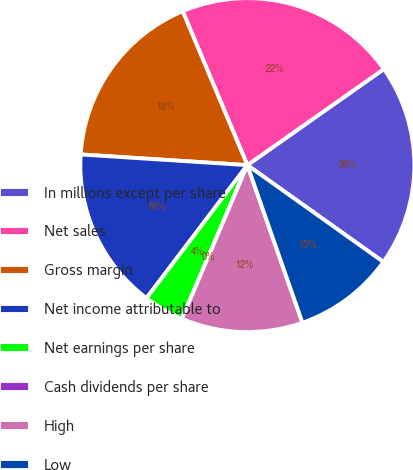<chart> <loc_0><loc_0><loc_500><loc_500><pie_chart><fcel>In millions except per share<fcel>Net sales<fcel>Gross margin<fcel>Net income attributable to<fcel>Net earnings per share<fcel>Cash dividends per share<fcel>High<fcel>Low<nl><fcel>19.61%<fcel>21.57%<fcel>17.65%<fcel>15.69%<fcel>3.92%<fcel>0.0%<fcel>11.76%<fcel>9.8%<nl></chart> 